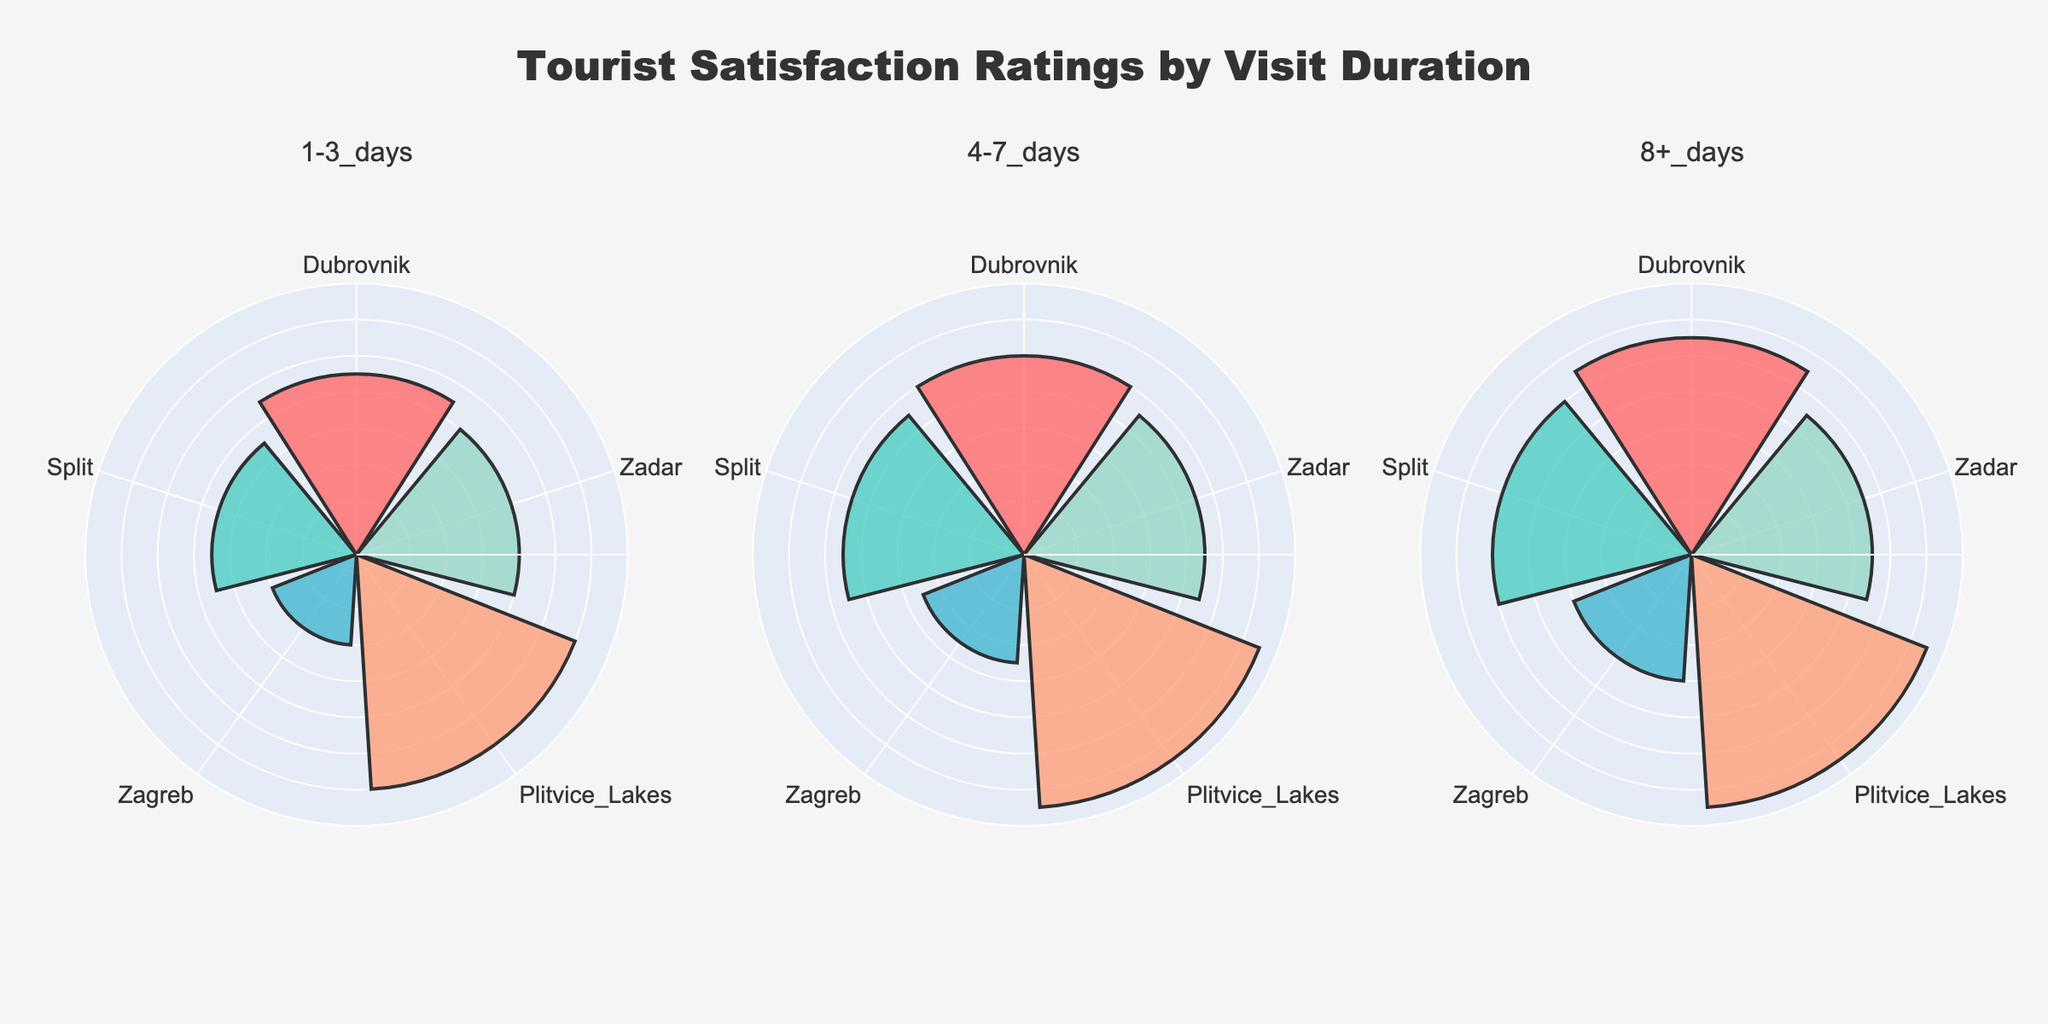What is the highest tourist satisfaction rating for the 1-3 days visit duration? For the 1-3 days visit duration, Plitvice Lakes has the highest rating. All that needs to be done is to check the radial length for each location in the corresponding subplot.
Answer: 4.8 Which location has a higher average rating for an 8+ day visit, Dubrovnik or Split? For an 8+ day visit, Dubrovnik has a rating of 4.7, and Split has a rating of 4.6. Dubrovnik's rating is higher than Split's.
Answer: Dubrovnik What is the average rating for Dubrovnik across all visit durations? To find the average rating, sum the ratings for Dubrovnik across all visit durations and divide by the number of durations: (4.5 + 4.6 + 4.7)/3 = 4.6
Answer: 4.6 Which city has the most consistent tourist satisfaction ratings across all durations? Compare the consistency of ratings by looking at the variations for each city. Plitvice Lakes has consistently high ratings (4.8, 4.9, 4.9), indicating the least variation.
Answer: Plitvice Lakes How does the rating for Zadar change from a 1-3 day visit to an 8+ day visit? To assess the change, consider the ratings of Zadar for a 1-3 day visit (4.4), and for an 8+ day visit (4.5). Zadar's rating increases slightly from 4.4 to 4.5.
Answer: Increases What is the title of the plot? The title of the plot is indicated at the top center of the figure. It reads "Tourist Satisfaction Ratings by Visit Duration."
Answer: Tourist Satisfaction Ratings by Visit Duration Which visit duration has the lowest tourist satisfaction rating for Zagreb, and what is that rating? Check Zagreb's ratings across all visit durations and note the lowest one. The lowest rating for Zagreb is 4.0 during the 1-3 days duration.
Answer: 4.0 during 1-3 days How many subplots are present in the figure? The figure displays three subplots, each corresponding to different visit durations (1-3 days, 4-7 days, and 8+ days).
Answer: 3 Does Plitvice Lakes maintain the highest rating across all visit durations? Yes, Plitvice Lakes consistently have the highest ratings in each subplot (4.8, 4.9, 4.9), indicating high tourist satisfaction regardless of visit duration.
Answer: Yes Compare the ratings for Split and Zagreb for a 4-7 day visit. Which city has a higher rating? For a 4-7 day visit, Split has a rating of 4.5 while Zagreb has a rating of 4.1. Split has a higher rating than Zagreb.
Answer: Split 